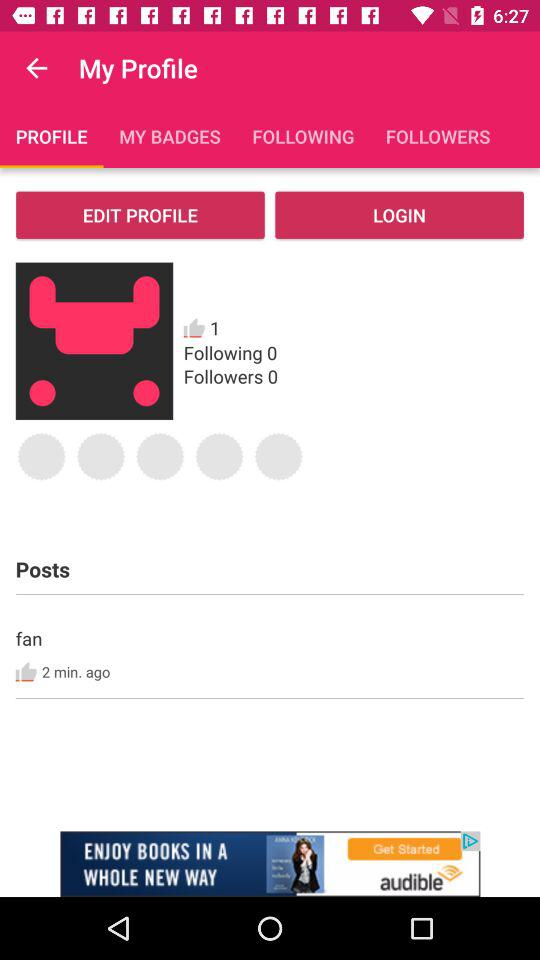How many minutes ago was the post posted? The post was posted 2 minutes ago. 